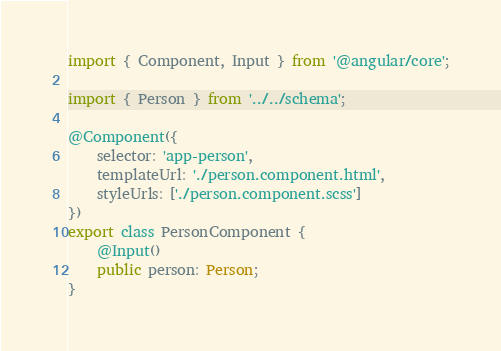Convert code to text. <code><loc_0><loc_0><loc_500><loc_500><_TypeScript_>import { Component, Input } from '@angular/core';

import { Person } from '../../schema';

@Component({
    selector: 'app-person',
    templateUrl: './person.component.html',
    styleUrls: ['./person.component.scss']
})
export class PersonComponent {
    @Input()
    public person: Person;
}
</code> 